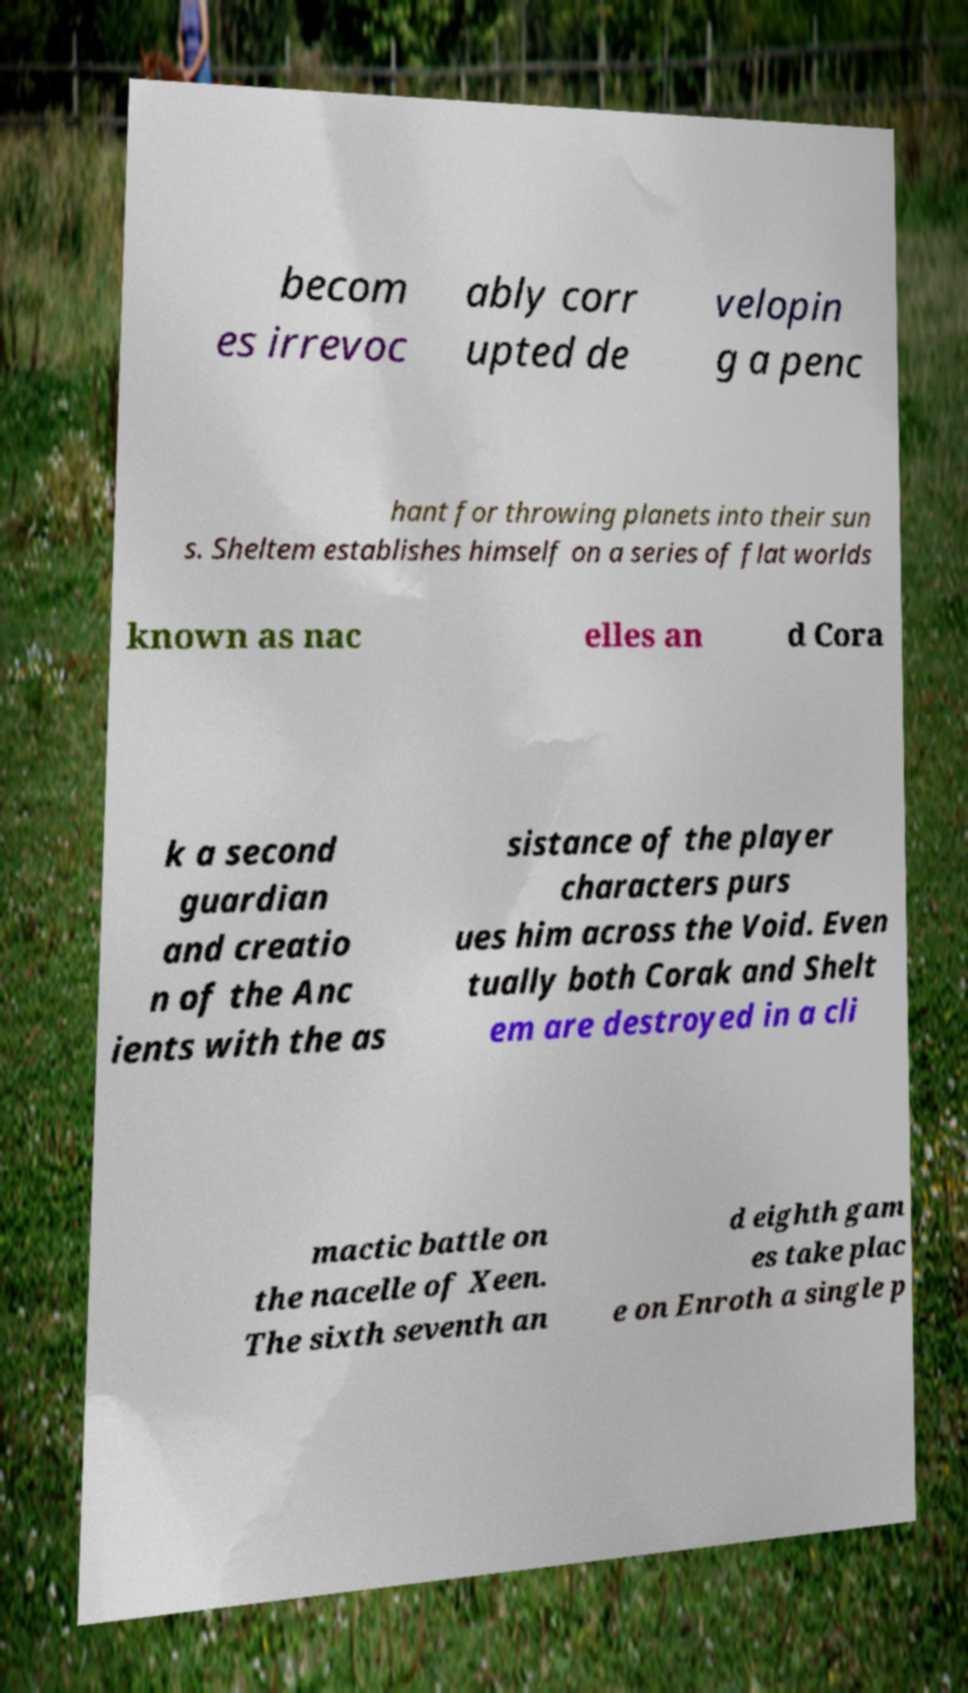What messages or text are displayed in this image? I need them in a readable, typed format. becom es irrevoc ably corr upted de velopin g a penc hant for throwing planets into their sun s. Sheltem establishes himself on a series of flat worlds known as nac elles an d Cora k a second guardian and creatio n of the Anc ients with the as sistance of the player characters purs ues him across the Void. Even tually both Corak and Shelt em are destroyed in a cli mactic battle on the nacelle of Xeen. The sixth seventh an d eighth gam es take plac e on Enroth a single p 